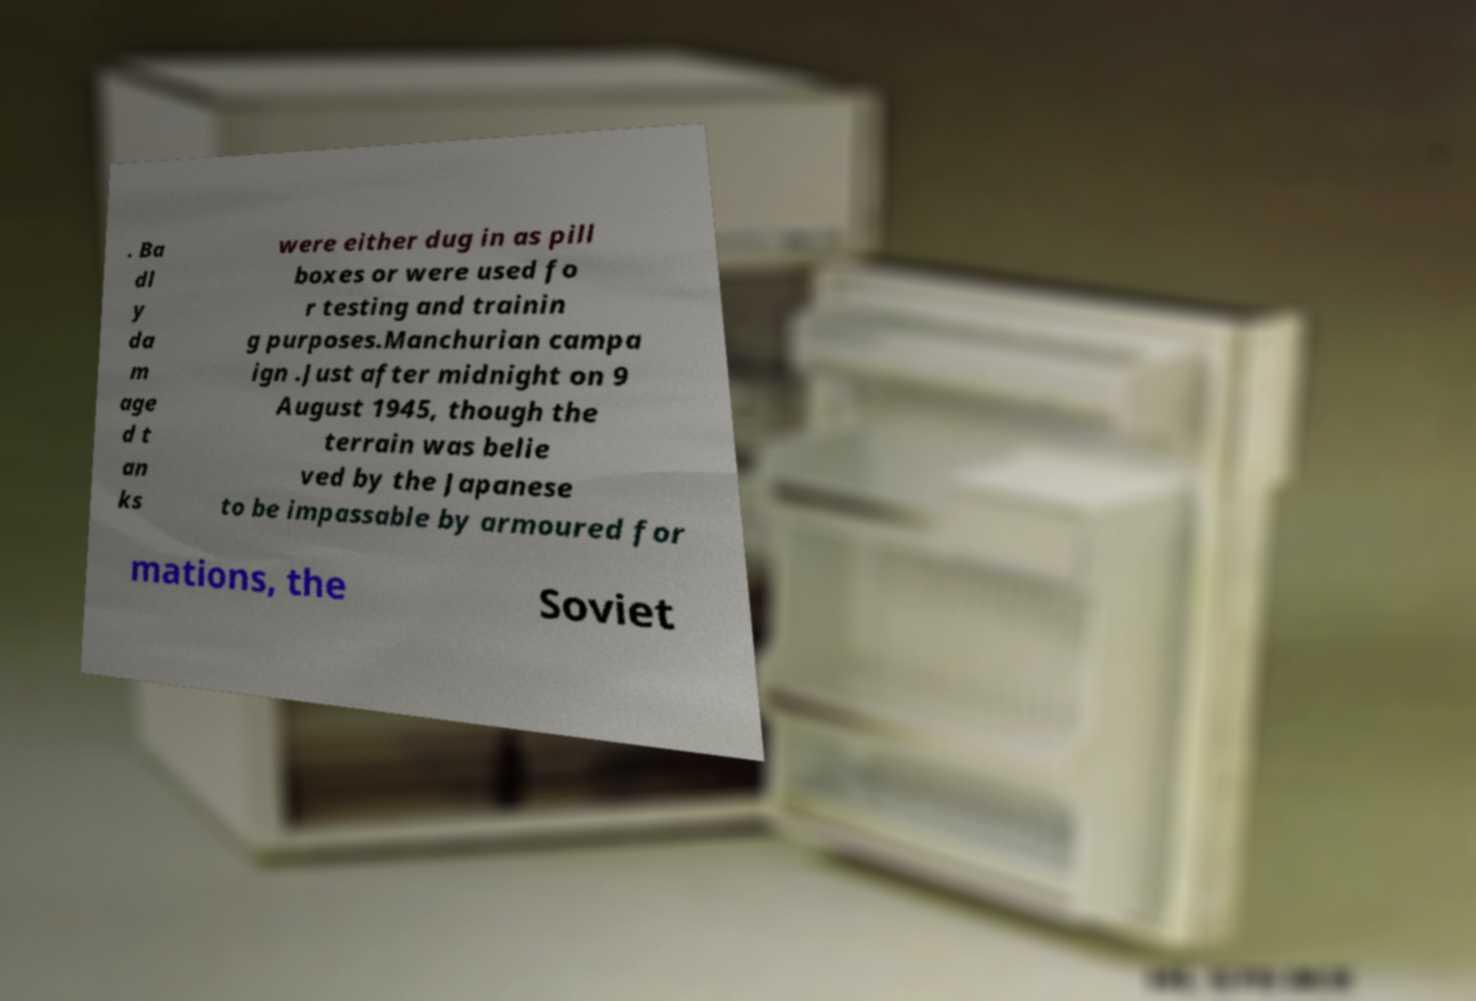Please read and relay the text visible in this image. What does it say? . Ba dl y da m age d t an ks were either dug in as pill boxes or were used fo r testing and trainin g purposes.Manchurian campa ign .Just after midnight on 9 August 1945, though the terrain was belie ved by the Japanese to be impassable by armoured for mations, the Soviet 